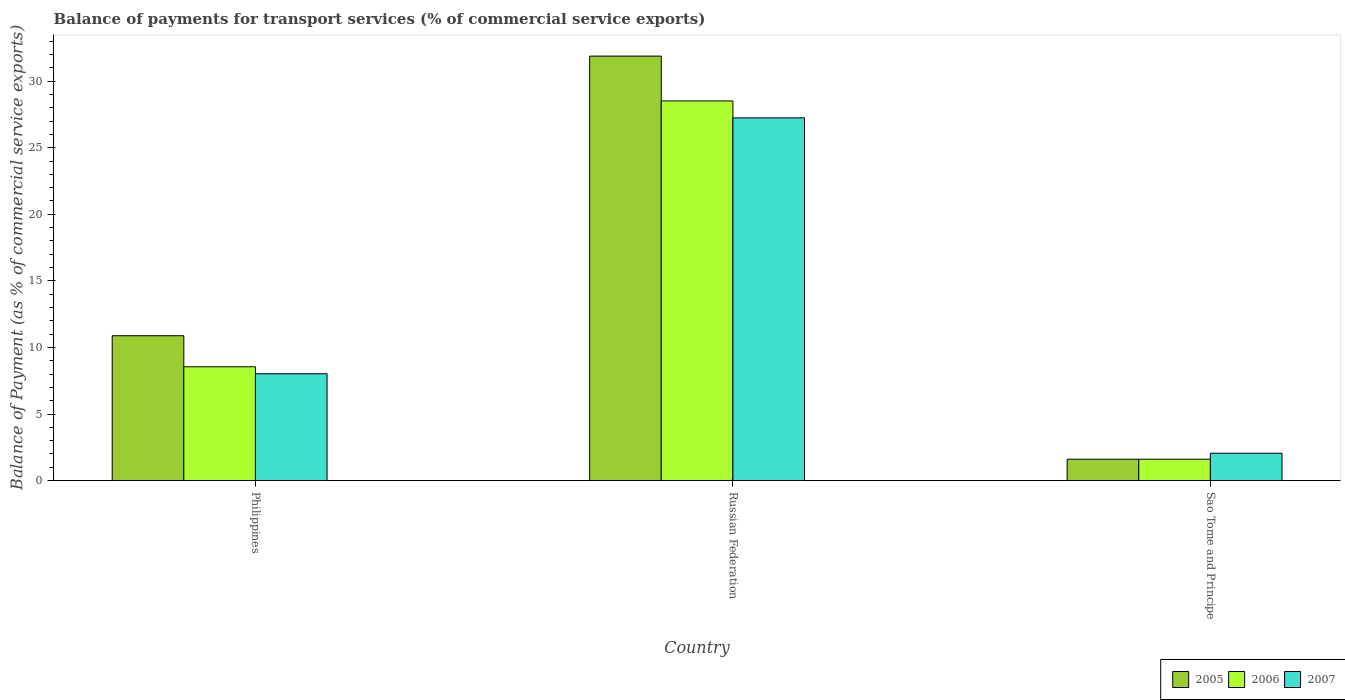How many groups of bars are there?
Your answer should be very brief. 3. Are the number of bars per tick equal to the number of legend labels?
Ensure brevity in your answer.  Yes. How many bars are there on the 2nd tick from the right?
Ensure brevity in your answer.  3. What is the label of the 1st group of bars from the left?
Your answer should be very brief. Philippines. In how many cases, is the number of bars for a given country not equal to the number of legend labels?
Offer a very short reply. 0. What is the balance of payments for transport services in 2006 in Sao Tome and Principe?
Provide a short and direct response. 1.61. Across all countries, what is the maximum balance of payments for transport services in 2006?
Offer a very short reply. 28.52. Across all countries, what is the minimum balance of payments for transport services in 2005?
Ensure brevity in your answer.  1.61. In which country was the balance of payments for transport services in 2006 maximum?
Make the answer very short. Russian Federation. In which country was the balance of payments for transport services in 2006 minimum?
Your answer should be compact. Sao Tome and Principe. What is the total balance of payments for transport services in 2006 in the graph?
Provide a short and direct response. 38.67. What is the difference between the balance of payments for transport services in 2005 in Russian Federation and that in Sao Tome and Principe?
Your response must be concise. 30.28. What is the difference between the balance of payments for transport services in 2007 in Sao Tome and Principe and the balance of payments for transport services in 2005 in Philippines?
Give a very brief answer. -8.83. What is the average balance of payments for transport services in 2005 per country?
Provide a short and direct response. 14.79. What is the difference between the balance of payments for transport services of/in 2006 and balance of payments for transport services of/in 2007 in Sao Tome and Principe?
Offer a terse response. -0.45. In how many countries, is the balance of payments for transport services in 2005 greater than 4 %?
Your answer should be very brief. 2. What is the ratio of the balance of payments for transport services in 2007 in Philippines to that in Russian Federation?
Keep it short and to the point. 0.29. What is the difference between the highest and the second highest balance of payments for transport services in 2005?
Offer a very short reply. -9.28. What is the difference between the highest and the lowest balance of payments for transport services in 2007?
Ensure brevity in your answer.  25.19. In how many countries, is the balance of payments for transport services in 2007 greater than the average balance of payments for transport services in 2007 taken over all countries?
Your answer should be compact. 1. Is the sum of the balance of payments for transport services in 2005 in Philippines and Sao Tome and Principe greater than the maximum balance of payments for transport services in 2007 across all countries?
Make the answer very short. No. What does the 3rd bar from the right in Philippines represents?
Offer a very short reply. 2005. What is the difference between two consecutive major ticks on the Y-axis?
Ensure brevity in your answer.  5. Are the values on the major ticks of Y-axis written in scientific E-notation?
Your answer should be very brief. No. Does the graph contain any zero values?
Your response must be concise. No. Does the graph contain grids?
Offer a terse response. No. Where does the legend appear in the graph?
Make the answer very short. Bottom right. How many legend labels are there?
Your answer should be very brief. 3. How are the legend labels stacked?
Provide a short and direct response. Horizontal. What is the title of the graph?
Your answer should be very brief. Balance of payments for transport services (% of commercial service exports). Does "1964" appear as one of the legend labels in the graph?
Ensure brevity in your answer.  No. What is the label or title of the X-axis?
Offer a terse response. Country. What is the label or title of the Y-axis?
Your answer should be very brief. Balance of Payment (as % of commercial service exports). What is the Balance of Payment (as % of commercial service exports) in 2005 in Philippines?
Provide a succinct answer. 10.88. What is the Balance of Payment (as % of commercial service exports) of 2006 in Philippines?
Give a very brief answer. 8.55. What is the Balance of Payment (as % of commercial service exports) of 2007 in Philippines?
Keep it short and to the point. 8.02. What is the Balance of Payment (as % of commercial service exports) in 2005 in Russian Federation?
Ensure brevity in your answer.  31.88. What is the Balance of Payment (as % of commercial service exports) in 2006 in Russian Federation?
Offer a terse response. 28.52. What is the Balance of Payment (as % of commercial service exports) of 2007 in Russian Federation?
Make the answer very short. 27.25. What is the Balance of Payment (as % of commercial service exports) in 2005 in Sao Tome and Principe?
Provide a short and direct response. 1.61. What is the Balance of Payment (as % of commercial service exports) of 2006 in Sao Tome and Principe?
Your answer should be very brief. 1.61. What is the Balance of Payment (as % of commercial service exports) of 2007 in Sao Tome and Principe?
Provide a short and direct response. 2.05. Across all countries, what is the maximum Balance of Payment (as % of commercial service exports) in 2005?
Keep it short and to the point. 31.88. Across all countries, what is the maximum Balance of Payment (as % of commercial service exports) in 2006?
Make the answer very short. 28.52. Across all countries, what is the maximum Balance of Payment (as % of commercial service exports) of 2007?
Offer a very short reply. 27.25. Across all countries, what is the minimum Balance of Payment (as % of commercial service exports) of 2005?
Ensure brevity in your answer.  1.61. Across all countries, what is the minimum Balance of Payment (as % of commercial service exports) in 2006?
Offer a very short reply. 1.61. Across all countries, what is the minimum Balance of Payment (as % of commercial service exports) in 2007?
Ensure brevity in your answer.  2.05. What is the total Balance of Payment (as % of commercial service exports) of 2005 in the graph?
Make the answer very short. 44.37. What is the total Balance of Payment (as % of commercial service exports) in 2006 in the graph?
Give a very brief answer. 38.67. What is the total Balance of Payment (as % of commercial service exports) of 2007 in the graph?
Ensure brevity in your answer.  37.32. What is the difference between the Balance of Payment (as % of commercial service exports) of 2005 in Philippines and that in Russian Federation?
Offer a very short reply. -21. What is the difference between the Balance of Payment (as % of commercial service exports) in 2006 in Philippines and that in Russian Federation?
Provide a succinct answer. -19.97. What is the difference between the Balance of Payment (as % of commercial service exports) in 2007 in Philippines and that in Russian Federation?
Provide a short and direct response. -19.22. What is the difference between the Balance of Payment (as % of commercial service exports) in 2005 in Philippines and that in Sao Tome and Principe?
Your response must be concise. 9.28. What is the difference between the Balance of Payment (as % of commercial service exports) of 2006 in Philippines and that in Sao Tome and Principe?
Make the answer very short. 6.94. What is the difference between the Balance of Payment (as % of commercial service exports) in 2007 in Philippines and that in Sao Tome and Principe?
Ensure brevity in your answer.  5.97. What is the difference between the Balance of Payment (as % of commercial service exports) in 2005 in Russian Federation and that in Sao Tome and Principe?
Your answer should be compact. 30.28. What is the difference between the Balance of Payment (as % of commercial service exports) in 2006 in Russian Federation and that in Sao Tome and Principe?
Provide a short and direct response. 26.91. What is the difference between the Balance of Payment (as % of commercial service exports) of 2007 in Russian Federation and that in Sao Tome and Principe?
Your response must be concise. 25.19. What is the difference between the Balance of Payment (as % of commercial service exports) in 2005 in Philippines and the Balance of Payment (as % of commercial service exports) in 2006 in Russian Federation?
Make the answer very short. -17.64. What is the difference between the Balance of Payment (as % of commercial service exports) in 2005 in Philippines and the Balance of Payment (as % of commercial service exports) in 2007 in Russian Federation?
Your answer should be very brief. -16.36. What is the difference between the Balance of Payment (as % of commercial service exports) of 2006 in Philippines and the Balance of Payment (as % of commercial service exports) of 2007 in Russian Federation?
Provide a short and direct response. -18.7. What is the difference between the Balance of Payment (as % of commercial service exports) in 2005 in Philippines and the Balance of Payment (as % of commercial service exports) in 2006 in Sao Tome and Principe?
Offer a terse response. 9.28. What is the difference between the Balance of Payment (as % of commercial service exports) of 2005 in Philippines and the Balance of Payment (as % of commercial service exports) of 2007 in Sao Tome and Principe?
Your answer should be compact. 8.83. What is the difference between the Balance of Payment (as % of commercial service exports) of 2006 in Philippines and the Balance of Payment (as % of commercial service exports) of 2007 in Sao Tome and Principe?
Your answer should be compact. 6.49. What is the difference between the Balance of Payment (as % of commercial service exports) of 2005 in Russian Federation and the Balance of Payment (as % of commercial service exports) of 2006 in Sao Tome and Principe?
Provide a short and direct response. 30.28. What is the difference between the Balance of Payment (as % of commercial service exports) in 2005 in Russian Federation and the Balance of Payment (as % of commercial service exports) in 2007 in Sao Tome and Principe?
Your answer should be very brief. 29.83. What is the difference between the Balance of Payment (as % of commercial service exports) in 2006 in Russian Federation and the Balance of Payment (as % of commercial service exports) in 2007 in Sao Tome and Principe?
Your response must be concise. 26.46. What is the average Balance of Payment (as % of commercial service exports) of 2005 per country?
Offer a very short reply. 14.79. What is the average Balance of Payment (as % of commercial service exports) in 2006 per country?
Keep it short and to the point. 12.89. What is the average Balance of Payment (as % of commercial service exports) in 2007 per country?
Your response must be concise. 12.44. What is the difference between the Balance of Payment (as % of commercial service exports) of 2005 and Balance of Payment (as % of commercial service exports) of 2006 in Philippines?
Offer a very short reply. 2.33. What is the difference between the Balance of Payment (as % of commercial service exports) of 2005 and Balance of Payment (as % of commercial service exports) of 2007 in Philippines?
Offer a very short reply. 2.86. What is the difference between the Balance of Payment (as % of commercial service exports) of 2006 and Balance of Payment (as % of commercial service exports) of 2007 in Philippines?
Your response must be concise. 0.52. What is the difference between the Balance of Payment (as % of commercial service exports) in 2005 and Balance of Payment (as % of commercial service exports) in 2006 in Russian Federation?
Your answer should be compact. 3.37. What is the difference between the Balance of Payment (as % of commercial service exports) in 2005 and Balance of Payment (as % of commercial service exports) in 2007 in Russian Federation?
Give a very brief answer. 4.64. What is the difference between the Balance of Payment (as % of commercial service exports) of 2006 and Balance of Payment (as % of commercial service exports) of 2007 in Russian Federation?
Your answer should be compact. 1.27. What is the difference between the Balance of Payment (as % of commercial service exports) in 2005 and Balance of Payment (as % of commercial service exports) in 2006 in Sao Tome and Principe?
Your answer should be very brief. 0. What is the difference between the Balance of Payment (as % of commercial service exports) in 2005 and Balance of Payment (as % of commercial service exports) in 2007 in Sao Tome and Principe?
Offer a terse response. -0.45. What is the difference between the Balance of Payment (as % of commercial service exports) in 2006 and Balance of Payment (as % of commercial service exports) in 2007 in Sao Tome and Principe?
Your answer should be very brief. -0.45. What is the ratio of the Balance of Payment (as % of commercial service exports) in 2005 in Philippines to that in Russian Federation?
Your answer should be compact. 0.34. What is the ratio of the Balance of Payment (as % of commercial service exports) in 2006 in Philippines to that in Russian Federation?
Your answer should be very brief. 0.3. What is the ratio of the Balance of Payment (as % of commercial service exports) in 2007 in Philippines to that in Russian Federation?
Provide a short and direct response. 0.29. What is the ratio of the Balance of Payment (as % of commercial service exports) in 2005 in Philippines to that in Sao Tome and Principe?
Your response must be concise. 6.78. What is the ratio of the Balance of Payment (as % of commercial service exports) of 2006 in Philippines to that in Sao Tome and Principe?
Ensure brevity in your answer.  5.32. What is the ratio of the Balance of Payment (as % of commercial service exports) in 2007 in Philippines to that in Sao Tome and Principe?
Your response must be concise. 3.91. What is the ratio of the Balance of Payment (as % of commercial service exports) of 2005 in Russian Federation to that in Sao Tome and Principe?
Make the answer very short. 19.86. What is the ratio of the Balance of Payment (as % of commercial service exports) of 2006 in Russian Federation to that in Sao Tome and Principe?
Make the answer very short. 17.76. What is the ratio of the Balance of Payment (as % of commercial service exports) of 2007 in Russian Federation to that in Sao Tome and Principe?
Provide a succinct answer. 13.26. What is the difference between the highest and the second highest Balance of Payment (as % of commercial service exports) of 2005?
Make the answer very short. 21. What is the difference between the highest and the second highest Balance of Payment (as % of commercial service exports) in 2006?
Provide a short and direct response. 19.97. What is the difference between the highest and the second highest Balance of Payment (as % of commercial service exports) in 2007?
Your response must be concise. 19.22. What is the difference between the highest and the lowest Balance of Payment (as % of commercial service exports) in 2005?
Offer a very short reply. 30.28. What is the difference between the highest and the lowest Balance of Payment (as % of commercial service exports) in 2006?
Offer a very short reply. 26.91. What is the difference between the highest and the lowest Balance of Payment (as % of commercial service exports) in 2007?
Offer a very short reply. 25.19. 